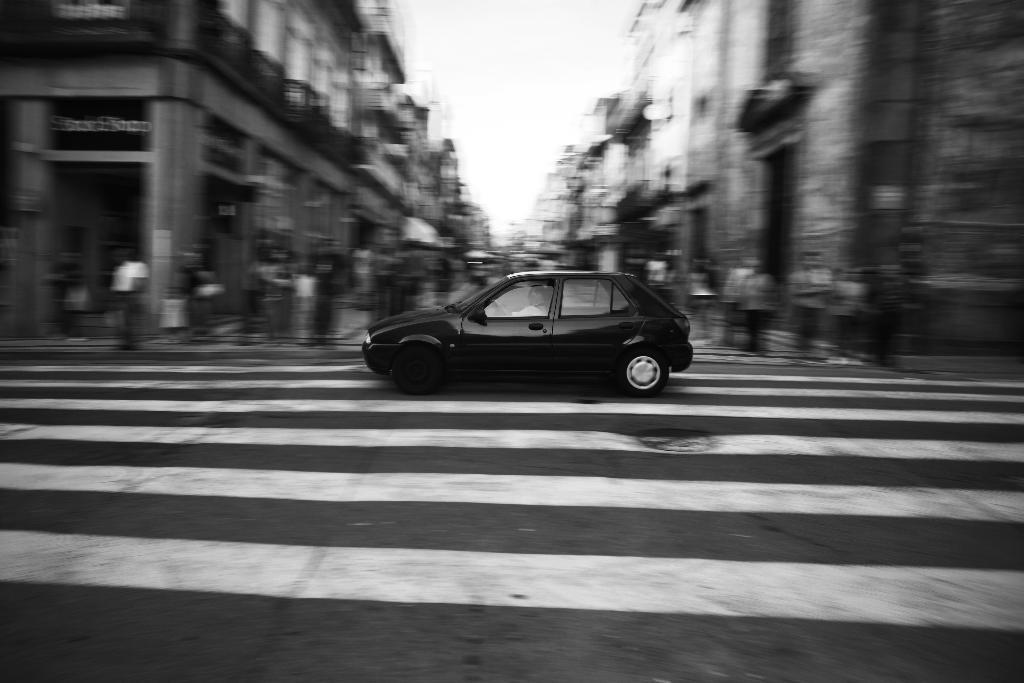What is the main subject in the middle of the image? There is a car in the middle of the image. What else can be seen on the road in the image? There is a crowd on the road in the image. What can be seen in the background of the image? There are buildings and the sky visible in the background of the image. Where was the image likely taken? The image appears to be taken on a road. What type of quince is being used to pave the road in the image? There is no quince present in the image, and the road does not appear to be paved with any fruit. 